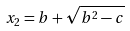<formula> <loc_0><loc_0><loc_500><loc_500>x _ { 2 } = b + \sqrt { b ^ { 2 } - c }</formula> 